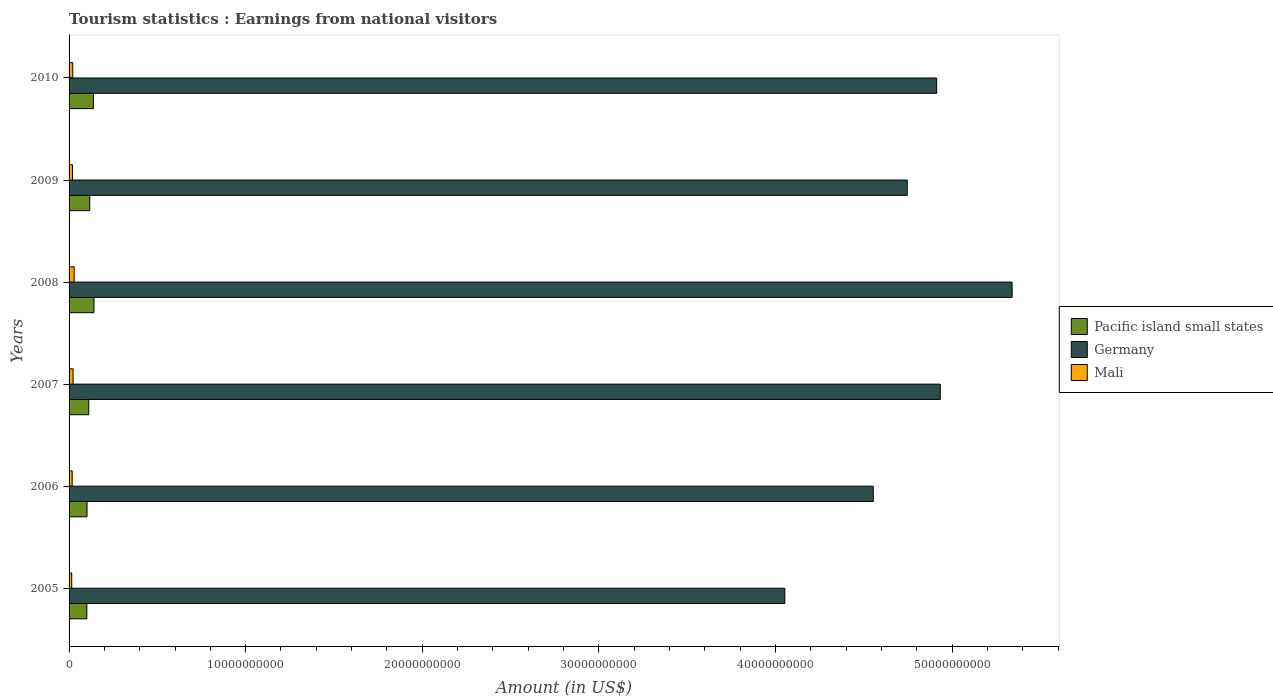How many groups of bars are there?
Make the answer very short. 6. How many bars are there on the 6th tick from the bottom?
Your response must be concise. 3. What is the label of the 5th group of bars from the top?
Ensure brevity in your answer.  2006. In how many cases, is the number of bars for a given year not equal to the number of legend labels?
Your response must be concise. 0. What is the earnings from national visitors in Pacific island small states in 2009?
Offer a very short reply. 1.17e+09. Across all years, what is the maximum earnings from national visitors in Pacific island small states?
Your answer should be compact. 1.41e+09. Across all years, what is the minimum earnings from national visitors in Pacific island small states?
Your answer should be very brief. 1.01e+09. In which year was the earnings from national visitors in Mali maximum?
Your response must be concise. 2008. In which year was the earnings from national visitors in Germany minimum?
Provide a short and direct response. 2005. What is the total earnings from national visitors in Pacific island small states in the graph?
Provide a succinct answer. 7.10e+09. What is the difference between the earnings from national visitors in Pacific island small states in 2006 and that in 2008?
Ensure brevity in your answer.  -3.93e+08. What is the difference between the earnings from national visitors in Pacific island small states in 2010 and the earnings from national visitors in Germany in 2008?
Make the answer very short. -5.20e+1. What is the average earnings from national visitors in Pacific island small states per year?
Your response must be concise. 1.18e+09. In the year 2007, what is the difference between the earnings from national visitors in Mali and earnings from national visitors in Pacific island small states?
Give a very brief answer. -8.88e+08. In how many years, is the earnings from national visitors in Pacific island small states greater than 18000000000 US$?
Offer a very short reply. 0. What is the ratio of the earnings from national visitors in Mali in 2006 to that in 2010?
Keep it short and to the point. 0.84. Is the difference between the earnings from national visitors in Mali in 2009 and 2010 greater than the difference between the earnings from national visitors in Pacific island small states in 2009 and 2010?
Provide a succinct answer. Yes. What is the difference between the highest and the second highest earnings from national visitors in Pacific island small states?
Give a very brief answer. 3.35e+07. What is the difference between the highest and the lowest earnings from national visitors in Germany?
Keep it short and to the point. 1.29e+1. In how many years, is the earnings from national visitors in Germany greater than the average earnings from national visitors in Germany taken over all years?
Make the answer very short. 3. Is the sum of the earnings from national visitors in Mali in 2005 and 2006 greater than the maximum earnings from national visitors in Pacific island small states across all years?
Make the answer very short. No. What does the 1st bar from the top in 2009 represents?
Provide a succinct answer. Mali. What is the difference between two consecutive major ticks on the X-axis?
Make the answer very short. 1.00e+1. Where does the legend appear in the graph?
Make the answer very short. Center right. How many legend labels are there?
Your response must be concise. 3. What is the title of the graph?
Keep it short and to the point. Tourism statistics : Earnings from national visitors. Does "Ecuador" appear as one of the legend labels in the graph?
Keep it short and to the point. No. What is the label or title of the Y-axis?
Your response must be concise. Years. What is the Amount (in US$) in Pacific island small states in 2005?
Ensure brevity in your answer.  1.01e+09. What is the Amount (in US$) of Germany in 2005?
Your answer should be compact. 4.05e+1. What is the Amount (in US$) of Mali in 2005?
Give a very brief answer. 1.49e+08. What is the Amount (in US$) in Pacific island small states in 2006?
Ensure brevity in your answer.  1.02e+09. What is the Amount (in US$) of Germany in 2006?
Give a very brief answer. 4.55e+1. What is the Amount (in US$) of Mali in 2006?
Keep it short and to the point. 1.75e+08. What is the Amount (in US$) of Pacific island small states in 2007?
Make the answer very short. 1.12e+09. What is the Amount (in US$) in Germany in 2007?
Offer a very short reply. 4.93e+1. What is the Amount (in US$) of Mali in 2007?
Your response must be concise. 2.27e+08. What is the Amount (in US$) of Pacific island small states in 2008?
Your answer should be very brief. 1.41e+09. What is the Amount (in US$) in Germany in 2008?
Provide a short and direct response. 5.34e+1. What is the Amount (in US$) of Mali in 2008?
Keep it short and to the point. 2.86e+08. What is the Amount (in US$) of Pacific island small states in 2009?
Ensure brevity in your answer.  1.17e+09. What is the Amount (in US$) of Germany in 2009?
Keep it short and to the point. 4.75e+1. What is the Amount (in US$) of Mali in 2009?
Provide a succinct answer. 1.96e+08. What is the Amount (in US$) of Pacific island small states in 2010?
Keep it short and to the point. 1.38e+09. What is the Amount (in US$) of Germany in 2010?
Your response must be concise. 4.91e+1. What is the Amount (in US$) of Mali in 2010?
Keep it short and to the point. 2.08e+08. Across all years, what is the maximum Amount (in US$) of Pacific island small states?
Ensure brevity in your answer.  1.41e+09. Across all years, what is the maximum Amount (in US$) in Germany?
Ensure brevity in your answer.  5.34e+1. Across all years, what is the maximum Amount (in US$) of Mali?
Offer a terse response. 2.86e+08. Across all years, what is the minimum Amount (in US$) of Pacific island small states?
Provide a short and direct response. 1.01e+09. Across all years, what is the minimum Amount (in US$) in Germany?
Offer a very short reply. 4.05e+1. Across all years, what is the minimum Amount (in US$) of Mali?
Keep it short and to the point. 1.49e+08. What is the total Amount (in US$) of Pacific island small states in the graph?
Make the answer very short. 7.10e+09. What is the total Amount (in US$) of Germany in the graph?
Offer a very short reply. 2.85e+11. What is the total Amount (in US$) in Mali in the graph?
Offer a terse response. 1.24e+09. What is the difference between the Amount (in US$) of Pacific island small states in 2005 and that in 2006?
Your answer should be very brief. -9.77e+06. What is the difference between the Amount (in US$) of Germany in 2005 and that in 2006?
Your answer should be compact. -5.01e+09. What is the difference between the Amount (in US$) in Mali in 2005 and that in 2006?
Make the answer very short. -2.62e+07. What is the difference between the Amount (in US$) of Pacific island small states in 2005 and that in 2007?
Ensure brevity in your answer.  -1.08e+08. What is the difference between the Amount (in US$) in Germany in 2005 and that in 2007?
Provide a short and direct response. -8.80e+09. What is the difference between the Amount (in US$) in Mali in 2005 and that in 2007?
Make the answer very short. -7.78e+07. What is the difference between the Amount (in US$) of Pacific island small states in 2005 and that in 2008?
Keep it short and to the point. -4.03e+08. What is the difference between the Amount (in US$) in Germany in 2005 and that in 2008?
Your answer should be very brief. -1.29e+1. What is the difference between the Amount (in US$) in Mali in 2005 and that in 2008?
Offer a very short reply. -1.37e+08. What is the difference between the Amount (in US$) in Pacific island small states in 2005 and that in 2009?
Make the answer very short. -1.64e+08. What is the difference between the Amount (in US$) in Germany in 2005 and that in 2009?
Provide a short and direct response. -6.93e+09. What is the difference between the Amount (in US$) in Mali in 2005 and that in 2009?
Provide a short and direct response. -4.68e+07. What is the difference between the Amount (in US$) in Pacific island small states in 2005 and that in 2010?
Your answer should be very brief. -3.69e+08. What is the difference between the Amount (in US$) of Germany in 2005 and that in 2010?
Offer a very short reply. -8.60e+09. What is the difference between the Amount (in US$) of Mali in 2005 and that in 2010?
Keep it short and to the point. -5.88e+07. What is the difference between the Amount (in US$) of Pacific island small states in 2006 and that in 2007?
Your answer should be very brief. -9.85e+07. What is the difference between the Amount (in US$) of Germany in 2006 and that in 2007?
Give a very brief answer. -3.80e+09. What is the difference between the Amount (in US$) in Mali in 2006 and that in 2007?
Your response must be concise. -5.16e+07. What is the difference between the Amount (in US$) of Pacific island small states in 2006 and that in 2008?
Your response must be concise. -3.93e+08. What is the difference between the Amount (in US$) of Germany in 2006 and that in 2008?
Make the answer very short. -7.86e+09. What is the difference between the Amount (in US$) of Mali in 2006 and that in 2008?
Your answer should be very brief. -1.11e+08. What is the difference between the Amount (in US$) in Pacific island small states in 2006 and that in 2009?
Give a very brief answer. -1.54e+08. What is the difference between the Amount (in US$) of Germany in 2006 and that in 2009?
Your response must be concise. -1.92e+09. What is the difference between the Amount (in US$) of Mali in 2006 and that in 2009?
Offer a terse response. -2.06e+07. What is the difference between the Amount (in US$) in Pacific island small states in 2006 and that in 2010?
Your answer should be compact. -3.60e+08. What is the difference between the Amount (in US$) of Germany in 2006 and that in 2010?
Make the answer very short. -3.59e+09. What is the difference between the Amount (in US$) of Mali in 2006 and that in 2010?
Your answer should be very brief. -3.26e+07. What is the difference between the Amount (in US$) of Pacific island small states in 2007 and that in 2008?
Provide a short and direct response. -2.95e+08. What is the difference between the Amount (in US$) in Germany in 2007 and that in 2008?
Ensure brevity in your answer.  -4.07e+09. What is the difference between the Amount (in US$) in Mali in 2007 and that in 2008?
Your response must be concise. -5.90e+07. What is the difference between the Amount (in US$) in Pacific island small states in 2007 and that in 2009?
Provide a short and direct response. -5.57e+07. What is the difference between the Amount (in US$) in Germany in 2007 and that in 2009?
Provide a short and direct response. 1.87e+09. What is the difference between the Amount (in US$) in Mali in 2007 and that in 2009?
Your answer should be compact. 3.10e+07. What is the difference between the Amount (in US$) in Pacific island small states in 2007 and that in 2010?
Give a very brief answer. -2.61e+08. What is the difference between the Amount (in US$) in Germany in 2007 and that in 2010?
Ensure brevity in your answer.  2.05e+08. What is the difference between the Amount (in US$) in Mali in 2007 and that in 2010?
Your response must be concise. 1.90e+07. What is the difference between the Amount (in US$) of Pacific island small states in 2008 and that in 2009?
Make the answer very short. 2.39e+08. What is the difference between the Amount (in US$) of Germany in 2008 and that in 2009?
Ensure brevity in your answer.  5.94e+09. What is the difference between the Amount (in US$) in Mali in 2008 and that in 2009?
Give a very brief answer. 9.00e+07. What is the difference between the Amount (in US$) in Pacific island small states in 2008 and that in 2010?
Offer a very short reply. 3.35e+07. What is the difference between the Amount (in US$) of Germany in 2008 and that in 2010?
Keep it short and to the point. 4.27e+09. What is the difference between the Amount (in US$) of Mali in 2008 and that in 2010?
Provide a short and direct response. 7.80e+07. What is the difference between the Amount (in US$) of Pacific island small states in 2009 and that in 2010?
Your answer should be very brief. -2.05e+08. What is the difference between the Amount (in US$) of Germany in 2009 and that in 2010?
Provide a succinct answer. -1.67e+09. What is the difference between the Amount (in US$) in Mali in 2009 and that in 2010?
Make the answer very short. -1.20e+07. What is the difference between the Amount (in US$) in Pacific island small states in 2005 and the Amount (in US$) in Germany in 2006?
Your answer should be compact. -4.45e+1. What is the difference between the Amount (in US$) in Pacific island small states in 2005 and the Amount (in US$) in Mali in 2006?
Offer a terse response. 8.32e+08. What is the difference between the Amount (in US$) of Germany in 2005 and the Amount (in US$) of Mali in 2006?
Your answer should be very brief. 4.04e+1. What is the difference between the Amount (in US$) of Pacific island small states in 2005 and the Amount (in US$) of Germany in 2007?
Keep it short and to the point. -4.83e+1. What is the difference between the Amount (in US$) in Pacific island small states in 2005 and the Amount (in US$) in Mali in 2007?
Provide a succinct answer. 7.80e+08. What is the difference between the Amount (in US$) of Germany in 2005 and the Amount (in US$) of Mali in 2007?
Your response must be concise. 4.03e+1. What is the difference between the Amount (in US$) of Pacific island small states in 2005 and the Amount (in US$) of Germany in 2008?
Give a very brief answer. -5.24e+1. What is the difference between the Amount (in US$) in Pacific island small states in 2005 and the Amount (in US$) in Mali in 2008?
Make the answer very short. 7.21e+08. What is the difference between the Amount (in US$) of Germany in 2005 and the Amount (in US$) of Mali in 2008?
Provide a succinct answer. 4.02e+1. What is the difference between the Amount (in US$) of Pacific island small states in 2005 and the Amount (in US$) of Germany in 2009?
Your answer should be very brief. -4.65e+1. What is the difference between the Amount (in US$) of Pacific island small states in 2005 and the Amount (in US$) of Mali in 2009?
Your response must be concise. 8.11e+08. What is the difference between the Amount (in US$) in Germany in 2005 and the Amount (in US$) in Mali in 2009?
Keep it short and to the point. 4.03e+1. What is the difference between the Amount (in US$) in Pacific island small states in 2005 and the Amount (in US$) in Germany in 2010?
Give a very brief answer. -4.81e+1. What is the difference between the Amount (in US$) of Pacific island small states in 2005 and the Amount (in US$) of Mali in 2010?
Your response must be concise. 7.99e+08. What is the difference between the Amount (in US$) in Germany in 2005 and the Amount (in US$) in Mali in 2010?
Provide a short and direct response. 4.03e+1. What is the difference between the Amount (in US$) in Pacific island small states in 2006 and the Amount (in US$) in Germany in 2007?
Your response must be concise. -4.83e+1. What is the difference between the Amount (in US$) in Pacific island small states in 2006 and the Amount (in US$) in Mali in 2007?
Ensure brevity in your answer.  7.90e+08. What is the difference between the Amount (in US$) in Germany in 2006 and the Amount (in US$) in Mali in 2007?
Provide a short and direct response. 4.53e+1. What is the difference between the Amount (in US$) in Pacific island small states in 2006 and the Amount (in US$) in Germany in 2008?
Ensure brevity in your answer.  -5.24e+1. What is the difference between the Amount (in US$) of Pacific island small states in 2006 and the Amount (in US$) of Mali in 2008?
Provide a short and direct response. 7.31e+08. What is the difference between the Amount (in US$) in Germany in 2006 and the Amount (in US$) in Mali in 2008?
Offer a very short reply. 4.53e+1. What is the difference between the Amount (in US$) in Pacific island small states in 2006 and the Amount (in US$) in Germany in 2009?
Offer a very short reply. -4.64e+1. What is the difference between the Amount (in US$) of Pacific island small states in 2006 and the Amount (in US$) of Mali in 2009?
Provide a short and direct response. 8.21e+08. What is the difference between the Amount (in US$) in Germany in 2006 and the Amount (in US$) in Mali in 2009?
Keep it short and to the point. 4.53e+1. What is the difference between the Amount (in US$) in Pacific island small states in 2006 and the Amount (in US$) in Germany in 2010?
Offer a terse response. -4.81e+1. What is the difference between the Amount (in US$) in Pacific island small states in 2006 and the Amount (in US$) in Mali in 2010?
Your response must be concise. 8.09e+08. What is the difference between the Amount (in US$) of Germany in 2006 and the Amount (in US$) of Mali in 2010?
Your answer should be compact. 4.53e+1. What is the difference between the Amount (in US$) in Pacific island small states in 2007 and the Amount (in US$) in Germany in 2008?
Provide a short and direct response. -5.23e+1. What is the difference between the Amount (in US$) in Pacific island small states in 2007 and the Amount (in US$) in Mali in 2008?
Your answer should be compact. 8.29e+08. What is the difference between the Amount (in US$) in Germany in 2007 and the Amount (in US$) in Mali in 2008?
Ensure brevity in your answer.  4.90e+1. What is the difference between the Amount (in US$) in Pacific island small states in 2007 and the Amount (in US$) in Germany in 2009?
Make the answer very short. -4.63e+1. What is the difference between the Amount (in US$) in Pacific island small states in 2007 and the Amount (in US$) in Mali in 2009?
Offer a terse response. 9.19e+08. What is the difference between the Amount (in US$) of Germany in 2007 and the Amount (in US$) of Mali in 2009?
Ensure brevity in your answer.  4.91e+1. What is the difference between the Amount (in US$) of Pacific island small states in 2007 and the Amount (in US$) of Germany in 2010?
Make the answer very short. -4.80e+1. What is the difference between the Amount (in US$) of Pacific island small states in 2007 and the Amount (in US$) of Mali in 2010?
Offer a very short reply. 9.07e+08. What is the difference between the Amount (in US$) in Germany in 2007 and the Amount (in US$) in Mali in 2010?
Your answer should be very brief. 4.91e+1. What is the difference between the Amount (in US$) in Pacific island small states in 2008 and the Amount (in US$) in Germany in 2009?
Give a very brief answer. -4.61e+1. What is the difference between the Amount (in US$) in Pacific island small states in 2008 and the Amount (in US$) in Mali in 2009?
Offer a terse response. 1.21e+09. What is the difference between the Amount (in US$) in Germany in 2008 and the Amount (in US$) in Mali in 2009?
Provide a succinct answer. 5.32e+1. What is the difference between the Amount (in US$) in Pacific island small states in 2008 and the Amount (in US$) in Germany in 2010?
Make the answer very short. -4.77e+1. What is the difference between the Amount (in US$) in Pacific island small states in 2008 and the Amount (in US$) in Mali in 2010?
Your answer should be very brief. 1.20e+09. What is the difference between the Amount (in US$) in Germany in 2008 and the Amount (in US$) in Mali in 2010?
Offer a very short reply. 5.32e+1. What is the difference between the Amount (in US$) in Pacific island small states in 2009 and the Amount (in US$) in Germany in 2010?
Your response must be concise. -4.80e+1. What is the difference between the Amount (in US$) of Pacific island small states in 2009 and the Amount (in US$) of Mali in 2010?
Offer a terse response. 9.63e+08. What is the difference between the Amount (in US$) of Germany in 2009 and the Amount (in US$) of Mali in 2010?
Your answer should be compact. 4.73e+1. What is the average Amount (in US$) of Pacific island small states per year?
Provide a succinct answer. 1.18e+09. What is the average Amount (in US$) in Germany per year?
Make the answer very short. 4.76e+1. What is the average Amount (in US$) of Mali per year?
Offer a very short reply. 2.07e+08. In the year 2005, what is the difference between the Amount (in US$) in Pacific island small states and Amount (in US$) in Germany?
Give a very brief answer. -3.95e+1. In the year 2005, what is the difference between the Amount (in US$) in Pacific island small states and Amount (in US$) in Mali?
Provide a succinct answer. 8.58e+08. In the year 2005, what is the difference between the Amount (in US$) of Germany and Amount (in US$) of Mali?
Your answer should be compact. 4.04e+1. In the year 2006, what is the difference between the Amount (in US$) of Pacific island small states and Amount (in US$) of Germany?
Give a very brief answer. -4.45e+1. In the year 2006, what is the difference between the Amount (in US$) of Pacific island small states and Amount (in US$) of Mali?
Ensure brevity in your answer.  8.42e+08. In the year 2006, what is the difference between the Amount (in US$) in Germany and Amount (in US$) in Mali?
Your answer should be very brief. 4.54e+1. In the year 2007, what is the difference between the Amount (in US$) in Pacific island small states and Amount (in US$) in Germany?
Your answer should be very brief. -4.82e+1. In the year 2007, what is the difference between the Amount (in US$) in Pacific island small states and Amount (in US$) in Mali?
Your answer should be very brief. 8.88e+08. In the year 2007, what is the difference between the Amount (in US$) of Germany and Amount (in US$) of Mali?
Offer a terse response. 4.91e+1. In the year 2008, what is the difference between the Amount (in US$) in Pacific island small states and Amount (in US$) in Germany?
Make the answer very short. -5.20e+1. In the year 2008, what is the difference between the Amount (in US$) in Pacific island small states and Amount (in US$) in Mali?
Your answer should be compact. 1.12e+09. In the year 2008, what is the difference between the Amount (in US$) of Germany and Amount (in US$) of Mali?
Offer a very short reply. 5.31e+1. In the year 2009, what is the difference between the Amount (in US$) in Pacific island small states and Amount (in US$) in Germany?
Your response must be concise. -4.63e+1. In the year 2009, what is the difference between the Amount (in US$) of Pacific island small states and Amount (in US$) of Mali?
Keep it short and to the point. 9.75e+08. In the year 2009, what is the difference between the Amount (in US$) in Germany and Amount (in US$) in Mali?
Offer a terse response. 4.73e+1. In the year 2010, what is the difference between the Amount (in US$) in Pacific island small states and Amount (in US$) in Germany?
Provide a short and direct response. -4.78e+1. In the year 2010, what is the difference between the Amount (in US$) in Pacific island small states and Amount (in US$) in Mali?
Provide a short and direct response. 1.17e+09. In the year 2010, what is the difference between the Amount (in US$) in Germany and Amount (in US$) in Mali?
Offer a terse response. 4.89e+1. What is the ratio of the Amount (in US$) of Germany in 2005 to that in 2006?
Your answer should be very brief. 0.89. What is the ratio of the Amount (in US$) in Mali in 2005 to that in 2006?
Ensure brevity in your answer.  0.85. What is the ratio of the Amount (in US$) in Pacific island small states in 2005 to that in 2007?
Offer a very short reply. 0.9. What is the ratio of the Amount (in US$) of Germany in 2005 to that in 2007?
Your answer should be compact. 0.82. What is the ratio of the Amount (in US$) of Mali in 2005 to that in 2007?
Your response must be concise. 0.66. What is the ratio of the Amount (in US$) in Germany in 2005 to that in 2008?
Your answer should be very brief. 0.76. What is the ratio of the Amount (in US$) in Mali in 2005 to that in 2008?
Give a very brief answer. 0.52. What is the ratio of the Amount (in US$) of Pacific island small states in 2005 to that in 2009?
Offer a terse response. 0.86. What is the ratio of the Amount (in US$) of Germany in 2005 to that in 2009?
Your answer should be compact. 0.85. What is the ratio of the Amount (in US$) of Mali in 2005 to that in 2009?
Your response must be concise. 0.76. What is the ratio of the Amount (in US$) in Pacific island small states in 2005 to that in 2010?
Provide a short and direct response. 0.73. What is the ratio of the Amount (in US$) in Germany in 2005 to that in 2010?
Give a very brief answer. 0.82. What is the ratio of the Amount (in US$) in Mali in 2005 to that in 2010?
Your answer should be compact. 0.72. What is the ratio of the Amount (in US$) in Pacific island small states in 2006 to that in 2007?
Provide a succinct answer. 0.91. What is the ratio of the Amount (in US$) in Germany in 2006 to that in 2007?
Ensure brevity in your answer.  0.92. What is the ratio of the Amount (in US$) of Mali in 2006 to that in 2007?
Provide a short and direct response. 0.77. What is the ratio of the Amount (in US$) of Pacific island small states in 2006 to that in 2008?
Your answer should be very brief. 0.72. What is the ratio of the Amount (in US$) of Germany in 2006 to that in 2008?
Your response must be concise. 0.85. What is the ratio of the Amount (in US$) in Mali in 2006 to that in 2008?
Your response must be concise. 0.61. What is the ratio of the Amount (in US$) in Pacific island small states in 2006 to that in 2009?
Your answer should be very brief. 0.87. What is the ratio of the Amount (in US$) in Germany in 2006 to that in 2009?
Make the answer very short. 0.96. What is the ratio of the Amount (in US$) of Mali in 2006 to that in 2009?
Your answer should be very brief. 0.89. What is the ratio of the Amount (in US$) in Pacific island small states in 2006 to that in 2010?
Your answer should be very brief. 0.74. What is the ratio of the Amount (in US$) of Germany in 2006 to that in 2010?
Provide a succinct answer. 0.93. What is the ratio of the Amount (in US$) of Mali in 2006 to that in 2010?
Keep it short and to the point. 0.84. What is the ratio of the Amount (in US$) of Pacific island small states in 2007 to that in 2008?
Your answer should be very brief. 0.79. What is the ratio of the Amount (in US$) in Germany in 2007 to that in 2008?
Provide a succinct answer. 0.92. What is the ratio of the Amount (in US$) of Mali in 2007 to that in 2008?
Keep it short and to the point. 0.79. What is the ratio of the Amount (in US$) in Pacific island small states in 2007 to that in 2009?
Your answer should be very brief. 0.95. What is the ratio of the Amount (in US$) of Germany in 2007 to that in 2009?
Your answer should be compact. 1.04. What is the ratio of the Amount (in US$) in Mali in 2007 to that in 2009?
Make the answer very short. 1.16. What is the ratio of the Amount (in US$) in Pacific island small states in 2007 to that in 2010?
Your answer should be compact. 0.81. What is the ratio of the Amount (in US$) of Mali in 2007 to that in 2010?
Your response must be concise. 1.09. What is the ratio of the Amount (in US$) of Pacific island small states in 2008 to that in 2009?
Offer a very short reply. 1.2. What is the ratio of the Amount (in US$) in Germany in 2008 to that in 2009?
Your response must be concise. 1.13. What is the ratio of the Amount (in US$) of Mali in 2008 to that in 2009?
Offer a terse response. 1.46. What is the ratio of the Amount (in US$) of Pacific island small states in 2008 to that in 2010?
Offer a terse response. 1.02. What is the ratio of the Amount (in US$) in Germany in 2008 to that in 2010?
Your answer should be very brief. 1.09. What is the ratio of the Amount (in US$) in Mali in 2008 to that in 2010?
Keep it short and to the point. 1.38. What is the ratio of the Amount (in US$) in Pacific island small states in 2009 to that in 2010?
Ensure brevity in your answer.  0.85. What is the ratio of the Amount (in US$) of Germany in 2009 to that in 2010?
Offer a terse response. 0.97. What is the ratio of the Amount (in US$) in Mali in 2009 to that in 2010?
Make the answer very short. 0.94. What is the difference between the highest and the second highest Amount (in US$) in Pacific island small states?
Your answer should be compact. 3.35e+07. What is the difference between the highest and the second highest Amount (in US$) in Germany?
Offer a terse response. 4.07e+09. What is the difference between the highest and the second highest Amount (in US$) of Mali?
Provide a succinct answer. 5.90e+07. What is the difference between the highest and the lowest Amount (in US$) in Pacific island small states?
Your response must be concise. 4.03e+08. What is the difference between the highest and the lowest Amount (in US$) in Germany?
Offer a terse response. 1.29e+1. What is the difference between the highest and the lowest Amount (in US$) in Mali?
Ensure brevity in your answer.  1.37e+08. 